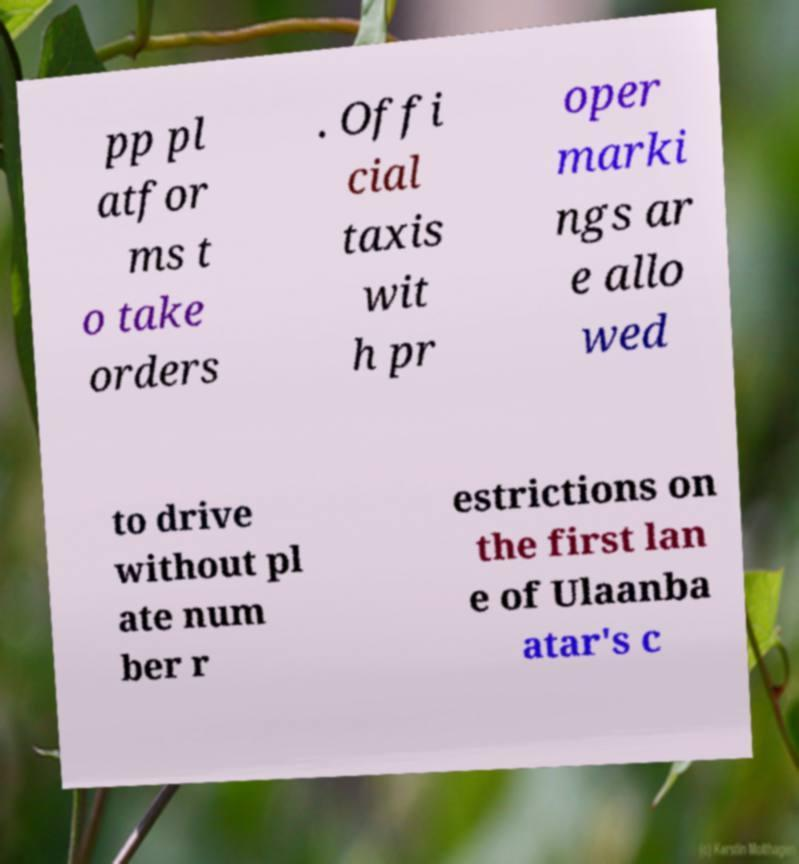What messages or text are displayed in this image? I need them in a readable, typed format. pp pl atfor ms t o take orders . Offi cial taxis wit h pr oper marki ngs ar e allo wed to drive without pl ate num ber r estrictions on the first lan e of Ulaanba atar's c 